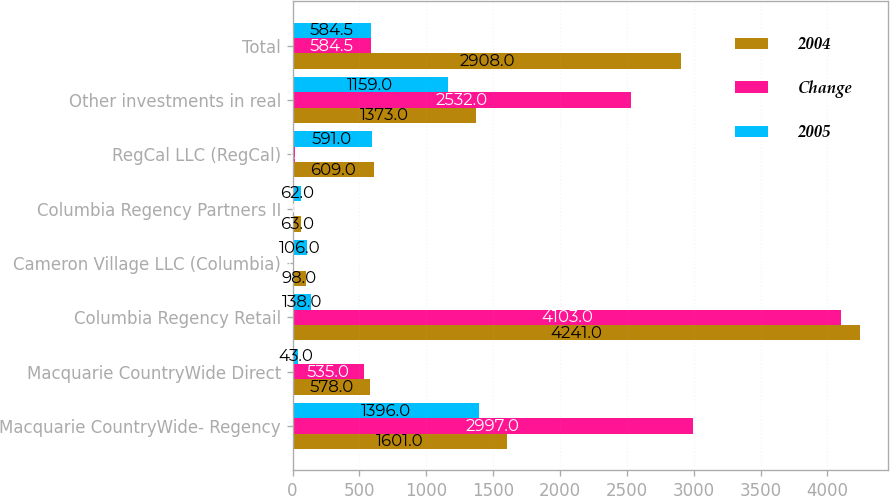Convert chart. <chart><loc_0><loc_0><loc_500><loc_500><stacked_bar_chart><ecel><fcel>Macquarie CountryWide- Regency<fcel>Macquarie CountryWide Direct<fcel>Columbia Regency Retail<fcel>Cameron Village LLC (Columbia)<fcel>Columbia Regency Partners II<fcel>RegCal LLC (RegCal)<fcel>Other investments in real<fcel>Total<nl><fcel>2004<fcel>1601<fcel>578<fcel>4241<fcel>98<fcel>63<fcel>609<fcel>1373<fcel>2908<nl><fcel>Change<fcel>2997<fcel>535<fcel>4103<fcel>8<fcel>1<fcel>18<fcel>2532<fcel>584.5<nl><fcel>2005<fcel>1396<fcel>43<fcel>138<fcel>106<fcel>62<fcel>591<fcel>1159<fcel>584.5<nl></chart> 